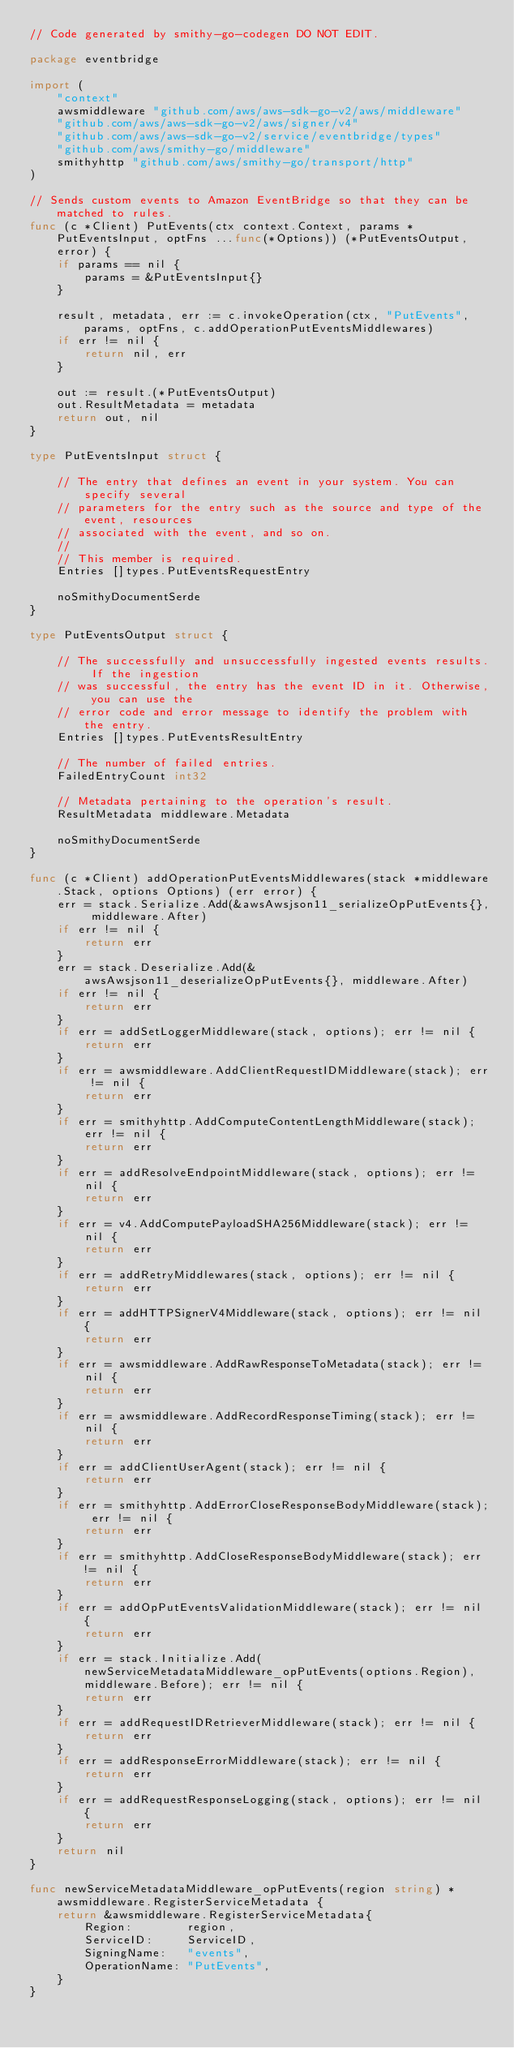Convert code to text. <code><loc_0><loc_0><loc_500><loc_500><_Go_>// Code generated by smithy-go-codegen DO NOT EDIT.

package eventbridge

import (
	"context"
	awsmiddleware "github.com/aws/aws-sdk-go-v2/aws/middleware"
	"github.com/aws/aws-sdk-go-v2/aws/signer/v4"
	"github.com/aws/aws-sdk-go-v2/service/eventbridge/types"
	"github.com/aws/smithy-go/middleware"
	smithyhttp "github.com/aws/smithy-go/transport/http"
)

// Sends custom events to Amazon EventBridge so that they can be matched to rules.
func (c *Client) PutEvents(ctx context.Context, params *PutEventsInput, optFns ...func(*Options)) (*PutEventsOutput, error) {
	if params == nil {
		params = &PutEventsInput{}
	}

	result, metadata, err := c.invokeOperation(ctx, "PutEvents", params, optFns, c.addOperationPutEventsMiddlewares)
	if err != nil {
		return nil, err
	}

	out := result.(*PutEventsOutput)
	out.ResultMetadata = metadata
	return out, nil
}

type PutEventsInput struct {

	// The entry that defines an event in your system. You can specify several
	// parameters for the entry such as the source and type of the event, resources
	// associated with the event, and so on.
	//
	// This member is required.
	Entries []types.PutEventsRequestEntry

	noSmithyDocumentSerde
}

type PutEventsOutput struct {

	// The successfully and unsuccessfully ingested events results. If the ingestion
	// was successful, the entry has the event ID in it. Otherwise, you can use the
	// error code and error message to identify the problem with the entry.
	Entries []types.PutEventsResultEntry

	// The number of failed entries.
	FailedEntryCount int32

	// Metadata pertaining to the operation's result.
	ResultMetadata middleware.Metadata

	noSmithyDocumentSerde
}

func (c *Client) addOperationPutEventsMiddlewares(stack *middleware.Stack, options Options) (err error) {
	err = stack.Serialize.Add(&awsAwsjson11_serializeOpPutEvents{}, middleware.After)
	if err != nil {
		return err
	}
	err = stack.Deserialize.Add(&awsAwsjson11_deserializeOpPutEvents{}, middleware.After)
	if err != nil {
		return err
	}
	if err = addSetLoggerMiddleware(stack, options); err != nil {
		return err
	}
	if err = awsmiddleware.AddClientRequestIDMiddleware(stack); err != nil {
		return err
	}
	if err = smithyhttp.AddComputeContentLengthMiddleware(stack); err != nil {
		return err
	}
	if err = addResolveEndpointMiddleware(stack, options); err != nil {
		return err
	}
	if err = v4.AddComputePayloadSHA256Middleware(stack); err != nil {
		return err
	}
	if err = addRetryMiddlewares(stack, options); err != nil {
		return err
	}
	if err = addHTTPSignerV4Middleware(stack, options); err != nil {
		return err
	}
	if err = awsmiddleware.AddRawResponseToMetadata(stack); err != nil {
		return err
	}
	if err = awsmiddleware.AddRecordResponseTiming(stack); err != nil {
		return err
	}
	if err = addClientUserAgent(stack); err != nil {
		return err
	}
	if err = smithyhttp.AddErrorCloseResponseBodyMiddleware(stack); err != nil {
		return err
	}
	if err = smithyhttp.AddCloseResponseBodyMiddleware(stack); err != nil {
		return err
	}
	if err = addOpPutEventsValidationMiddleware(stack); err != nil {
		return err
	}
	if err = stack.Initialize.Add(newServiceMetadataMiddleware_opPutEvents(options.Region), middleware.Before); err != nil {
		return err
	}
	if err = addRequestIDRetrieverMiddleware(stack); err != nil {
		return err
	}
	if err = addResponseErrorMiddleware(stack); err != nil {
		return err
	}
	if err = addRequestResponseLogging(stack, options); err != nil {
		return err
	}
	return nil
}

func newServiceMetadataMiddleware_opPutEvents(region string) *awsmiddleware.RegisterServiceMetadata {
	return &awsmiddleware.RegisterServiceMetadata{
		Region:        region,
		ServiceID:     ServiceID,
		SigningName:   "events",
		OperationName: "PutEvents",
	}
}
</code> 